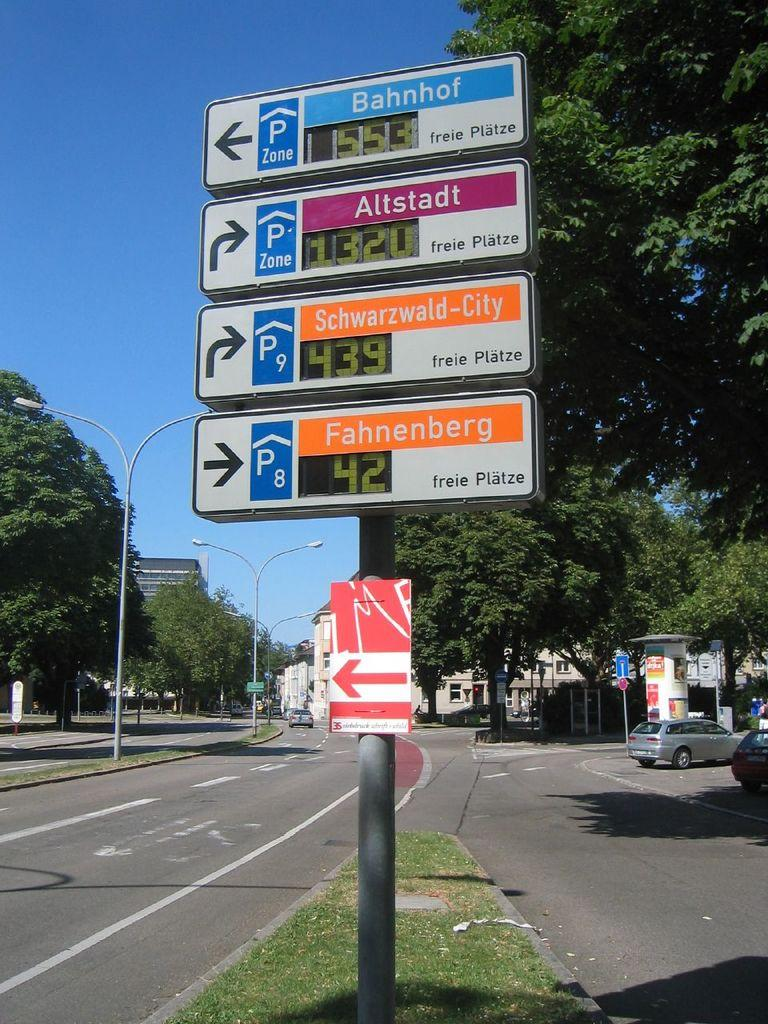<image>
Present a compact description of the photo's key features. Directional signs show Bahnhof to the left and Altstadt to the right. 